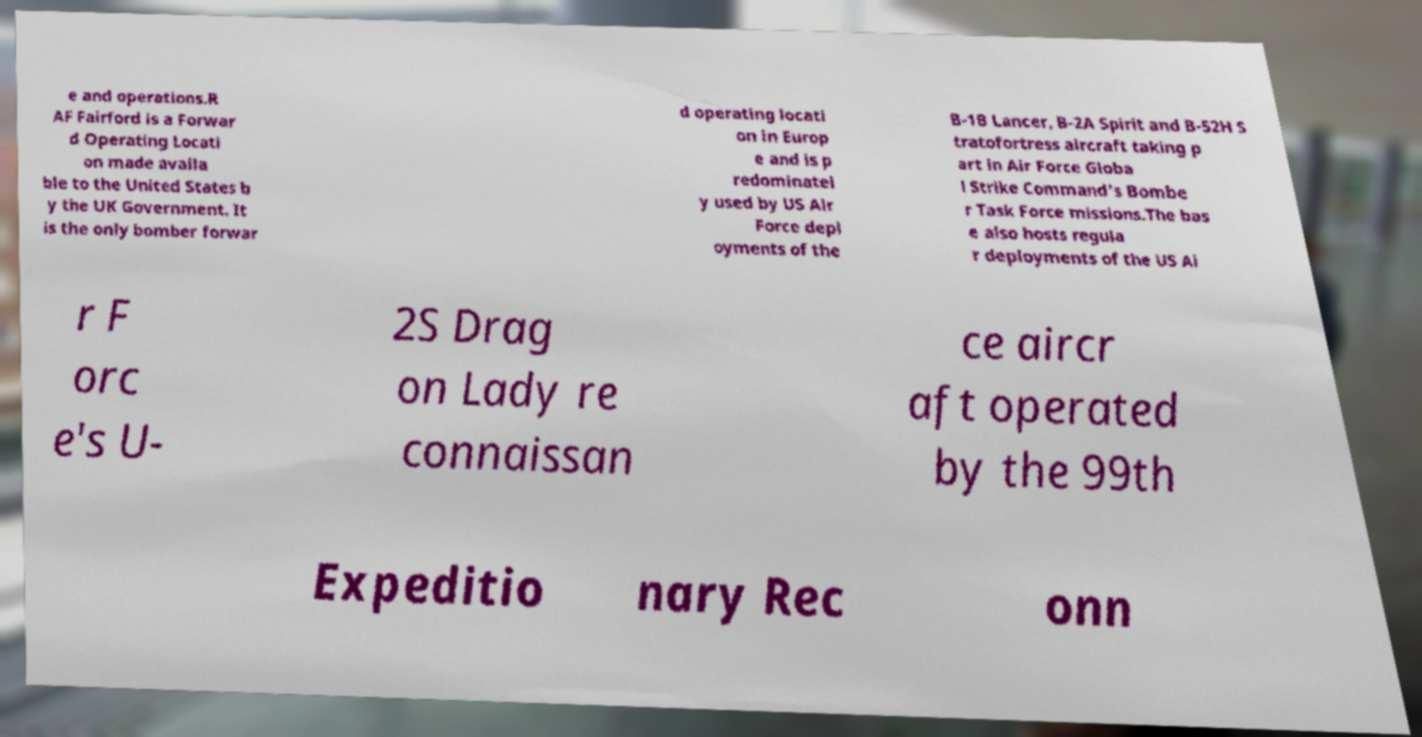I need the written content from this picture converted into text. Can you do that? e and operations.R AF Fairford is a Forwar d Operating Locati on made availa ble to the United States b y the UK Government. It is the only bomber forwar d operating locati on in Europ e and is p redominatel y used by US Air Force depl oyments of the B-1B Lancer, B-2A Spirit and B-52H S tratofortress aircraft taking p art in Air Force Globa l Strike Command's Bombe r Task Force missions.The bas e also hosts regula r deployments of the US Ai r F orc e's U- 2S Drag on Lady re connaissan ce aircr aft operated by the 99th Expeditio nary Rec onn 